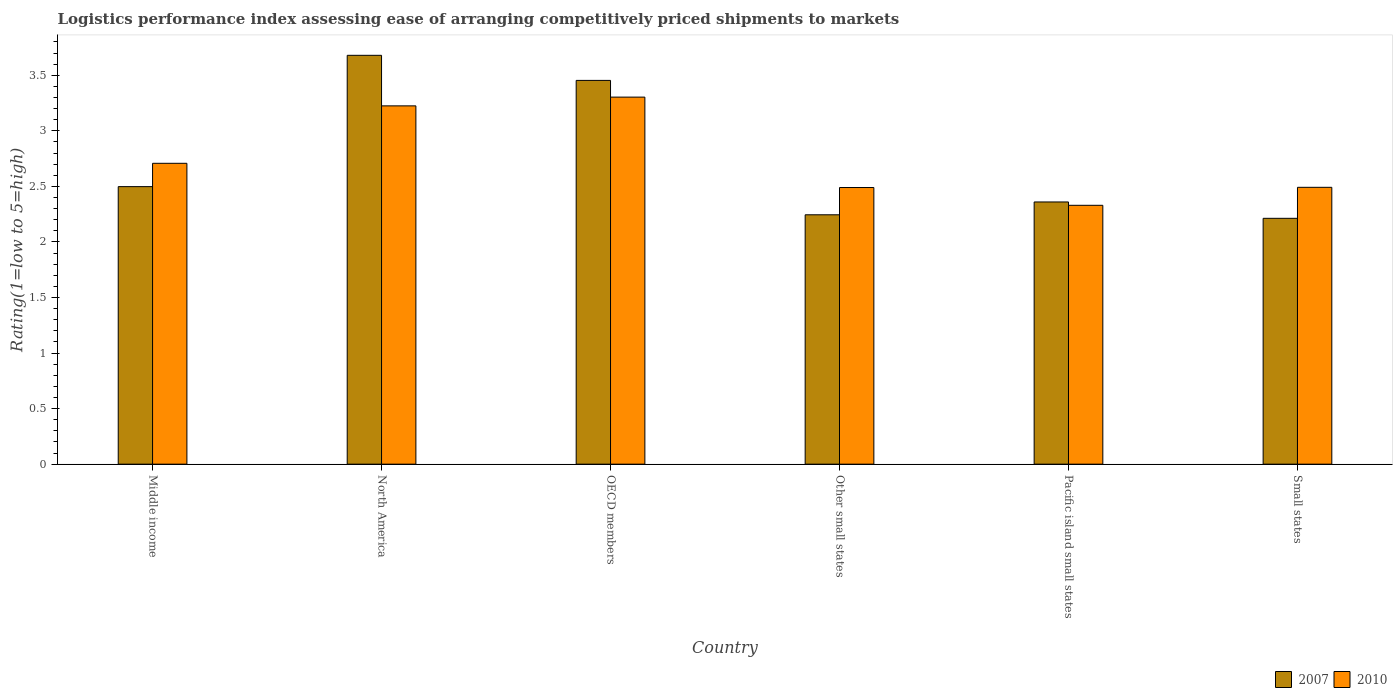How many different coloured bars are there?
Offer a very short reply. 2. How many groups of bars are there?
Give a very brief answer. 6. Are the number of bars on each tick of the X-axis equal?
Keep it short and to the point. Yes. How many bars are there on the 5th tick from the right?
Your answer should be very brief. 2. What is the label of the 5th group of bars from the left?
Your answer should be compact. Pacific island small states. What is the Logistic performance index in 2010 in OECD members?
Keep it short and to the point. 3.3. Across all countries, what is the maximum Logistic performance index in 2007?
Ensure brevity in your answer.  3.68. Across all countries, what is the minimum Logistic performance index in 2007?
Offer a terse response. 2.21. In which country was the Logistic performance index in 2007 maximum?
Your answer should be compact. North America. In which country was the Logistic performance index in 2007 minimum?
Offer a very short reply. Small states. What is the total Logistic performance index in 2010 in the graph?
Make the answer very short. 16.55. What is the difference between the Logistic performance index in 2010 in North America and that in Pacific island small states?
Provide a succinct answer. 0.9. What is the difference between the Logistic performance index in 2010 in Pacific island small states and the Logistic performance index in 2007 in North America?
Your answer should be compact. -1.35. What is the average Logistic performance index in 2007 per country?
Offer a terse response. 2.74. What is the difference between the Logistic performance index of/in 2007 and Logistic performance index of/in 2010 in Small states?
Your response must be concise. -0.28. What is the ratio of the Logistic performance index in 2010 in North America to that in Other small states?
Your answer should be compact. 1.3. Is the difference between the Logistic performance index in 2007 in North America and Small states greater than the difference between the Logistic performance index in 2010 in North America and Small states?
Ensure brevity in your answer.  Yes. What is the difference between the highest and the second highest Logistic performance index in 2010?
Your response must be concise. 0.52. What is the difference between the highest and the lowest Logistic performance index in 2010?
Provide a short and direct response. 0.97. In how many countries, is the Logistic performance index in 2007 greater than the average Logistic performance index in 2007 taken over all countries?
Your answer should be compact. 2. Does the graph contain any zero values?
Make the answer very short. No. Does the graph contain grids?
Your answer should be compact. No. Where does the legend appear in the graph?
Make the answer very short. Bottom right. How many legend labels are there?
Your answer should be compact. 2. How are the legend labels stacked?
Provide a short and direct response. Horizontal. What is the title of the graph?
Give a very brief answer. Logistics performance index assessing ease of arranging competitively priced shipments to markets. What is the label or title of the Y-axis?
Offer a very short reply. Rating(1=low to 5=high). What is the Rating(1=low to 5=high) in 2007 in Middle income?
Offer a terse response. 2.5. What is the Rating(1=low to 5=high) of 2010 in Middle income?
Make the answer very short. 2.71. What is the Rating(1=low to 5=high) of 2007 in North America?
Your answer should be very brief. 3.68. What is the Rating(1=low to 5=high) of 2010 in North America?
Offer a very short reply. 3.23. What is the Rating(1=low to 5=high) of 2007 in OECD members?
Your answer should be compact. 3.45. What is the Rating(1=low to 5=high) of 2010 in OECD members?
Keep it short and to the point. 3.3. What is the Rating(1=low to 5=high) in 2007 in Other small states?
Offer a terse response. 2.24. What is the Rating(1=low to 5=high) of 2010 in Other small states?
Give a very brief answer. 2.49. What is the Rating(1=low to 5=high) in 2007 in Pacific island small states?
Give a very brief answer. 2.36. What is the Rating(1=low to 5=high) of 2010 in Pacific island small states?
Offer a very short reply. 2.33. What is the Rating(1=low to 5=high) of 2007 in Small states?
Your answer should be very brief. 2.21. What is the Rating(1=low to 5=high) of 2010 in Small states?
Provide a short and direct response. 2.49. Across all countries, what is the maximum Rating(1=low to 5=high) of 2007?
Your response must be concise. 3.68. Across all countries, what is the maximum Rating(1=low to 5=high) in 2010?
Give a very brief answer. 3.3. Across all countries, what is the minimum Rating(1=low to 5=high) in 2007?
Your answer should be compact. 2.21. Across all countries, what is the minimum Rating(1=low to 5=high) in 2010?
Provide a short and direct response. 2.33. What is the total Rating(1=low to 5=high) of 2007 in the graph?
Provide a succinct answer. 16.45. What is the total Rating(1=low to 5=high) of 2010 in the graph?
Provide a short and direct response. 16.55. What is the difference between the Rating(1=low to 5=high) in 2007 in Middle income and that in North America?
Make the answer very short. -1.18. What is the difference between the Rating(1=low to 5=high) of 2010 in Middle income and that in North America?
Provide a short and direct response. -0.52. What is the difference between the Rating(1=low to 5=high) in 2007 in Middle income and that in OECD members?
Make the answer very short. -0.96. What is the difference between the Rating(1=low to 5=high) in 2010 in Middle income and that in OECD members?
Keep it short and to the point. -0.6. What is the difference between the Rating(1=low to 5=high) of 2007 in Middle income and that in Other small states?
Make the answer very short. 0.25. What is the difference between the Rating(1=low to 5=high) of 2010 in Middle income and that in Other small states?
Keep it short and to the point. 0.22. What is the difference between the Rating(1=low to 5=high) in 2007 in Middle income and that in Pacific island small states?
Your response must be concise. 0.14. What is the difference between the Rating(1=low to 5=high) in 2010 in Middle income and that in Pacific island small states?
Offer a terse response. 0.38. What is the difference between the Rating(1=low to 5=high) in 2007 in Middle income and that in Small states?
Offer a very short reply. 0.29. What is the difference between the Rating(1=low to 5=high) in 2010 in Middle income and that in Small states?
Provide a succinct answer. 0.22. What is the difference between the Rating(1=low to 5=high) of 2007 in North America and that in OECD members?
Make the answer very short. 0.23. What is the difference between the Rating(1=low to 5=high) in 2010 in North America and that in OECD members?
Your answer should be very brief. -0.08. What is the difference between the Rating(1=low to 5=high) in 2007 in North America and that in Other small states?
Your answer should be compact. 1.44. What is the difference between the Rating(1=low to 5=high) of 2010 in North America and that in Other small states?
Provide a succinct answer. 0.73. What is the difference between the Rating(1=low to 5=high) of 2007 in North America and that in Pacific island small states?
Make the answer very short. 1.32. What is the difference between the Rating(1=low to 5=high) in 2010 in North America and that in Pacific island small states?
Your answer should be very brief. 0.9. What is the difference between the Rating(1=low to 5=high) of 2007 in North America and that in Small states?
Provide a short and direct response. 1.47. What is the difference between the Rating(1=low to 5=high) of 2010 in North America and that in Small states?
Ensure brevity in your answer.  0.73. What is the difference between the Rating(1=low to 5=high) of 2007 in OECD members and that in Other small states?
Provide a short and direct response. 1.21. What is the difference between the Rating(1=low to 5=high) of 2010 in OECD members and that in Other small states?
Provide a short and direct response. 0.81. What is the difference between the Rating(1=low to 5=high) of 2007 in OECD members and that in Pacific island small states?
Provide a succinct answer. 1.09. What is the difference between the Rating(1=low to 5=high) in 2010 in OECD members and that in Pacific island small states?
Keep it short and to the point. 0.97. What is the difference between the Rating(1=low to 5=high) of 2007 in OECD members and that in Small states?
Ensure brevity in your answer.  1.24. What is the difference between the Rating(1=low to 5=high) of 2010 in OECD members and that in Small states?
Make the answer very short. 0.81. What is the difference between the Rating(1=low to 5=high) in 2007 in Other small states and that in Pacific island small states?
Make the answer very short. -0.12. What is the difference between the Rating(1=low to 5=high) of 2010 in Other small states and that in Pacific island small states?
Provide a short and direct response. 0.16. What is the difference between the Rating(1=low to 5=high) of 2007 in Other small states and that in Small states?
Your response must be concise. 0.03. What is the difference between the Rating(1=low to 5=high) of 2010 in Other small states and that in Small states?
Your response must be concise. -0. What is the difference between the Rating(1=low to 5=high) of 2007 in Pacific island small states and that in Small states?
Your response must be concise. 0.15. What is the difference between the Rating(1=low to 5=high) in 2010 in Pacific island small states and that in Small states?
Your answer should be very brief. -0.16. What is the difference between the Rating(1=low to 5=high) in 2007 in Middle income and the Rating(1=low to 5=high) in 2010 in North America?
Your response must be concise. -0.73. What is the difference between the Rating(1=low to 5=high) of 2007 in Middle income and the Rating(1=low to 5=high) of 2010 in OECD members?
Offer a terse response. -0.81. What is the difference between the Rating(1=low to 5=high) of 2007 in Middle income and the Rating(1=low to 5=high) of 2010 in Other small states?
Give a very brief answer. 0.01. What is the difference between the Rating(1=low to 5=high) in 2007 in Middle income and the Rating(1=low to 5=high) in 2010 in Pacific island small states?
Your answer should be compact. 0.17. What is the difference between the Rating(1=low to 5=high) in 2007 in Middle income and the Rating(1=low to 5=high) in 2010 in Small states?
Provide a succinct answer. 0.01. What is the difference between the Rating(1=low to 5=high) of 2007 in North America and the Rating(1=low to 5=high) of 2010 in OECD members?
Offer a very short reply. 0.38. What is the difference between the Rating(1=low to 5=high) of 2007 in North America and the Rating(1=low to 5=high) of 2010 in Other small states?
Ensure brevity in your answer.  1.19. What is the difference between the Rating(1=low to 5=high) of 2007 in North America and the Rating(1=low to 5=high) of 2010 in Pacific island small states?
Give a very brief answer. 1.35. What is the difference between the Rating(1=low to 5=high) in 2007 in North America and the Rating(1=low to 5=high) in 2010 in Small states?
Keep it short and to the point. 1.19. What is the difference between the Rating(1=low to 5=high) in 2007 in OECD members and the Rating(1=low to 5=high) in 2010 in Other small states?
Make the answer very short. 0.96. What is the difference between the Rating(1=low to 5=high) in 2007 in OECD members and the Rating(1=low to 5=high) in 2010 in Pacific island small states?
Make the answer very short. 1.12. What is the difference between the Rating(1=low to 5=high) of 2007 in OECD members and the Rating(1=low to 5=high) of 2010 in Small states?
Your answer should be compact. 0.96. What is the difference between the Rating(1=low to 5=high) in 2007 in Other small states and the Rating(1=low to 5=high) in 2010 in Pacific island small states?
Provide a succinct answer. -0.09. What is the difference between the Rating(1=low to 5=high) in 2007 in Other small states and the Rating(1=low to 5=high) in 2010 in Small states?
Your answer should be compact. -0.25. What is the difference between the Rating(1=low to 5=high) of 2007 in Pacific island small states and the Rating(1=low to 5=high) of 2010 in Small states?
Your response must be concise. -0.13. What is the average Rating(1=low to 5=high) in 2007 per country?
Provide a succinct answer. 2.74. What is the average Rating(1=low to 5=high) in 2010 per country?
Ensure brevity in your answer.  2.76. What is the difference between the Rating(1=low to 5=high) in 2007 and Rating(1=low to 5=high) in 2010 in Middle income?
Offer a very short reply. -0.21. What is the difference between the Rating(1=low to 5=high) in 2007 and Rating(1=low to 5=high) in 2010 in North America?
Provide a short and direct response. 0.46. What is the difference between the Rating(1=low to 5=high) of 2007 and Rating(1=low to 5=high) of 2010 in OECD members?
Provide a succinct answer. 0.15. What is the difference between the Rating(1=low to 5=high) of 2007 and Rating(1=low to 5=high) of 2010 in Other small states?
Provide a succinct answer. -0.25. What is the difference between the Rating(1=low to 5=high) in 2007 and Rating(1=low to 5=high) in 2010 in Pacific island small states?
Provide a succinct answer. 0.03. What is the difference between the Rating(1=low to 5=high) in 2007 and Rating(1=low to 5=high) in 2010 in Small states?
Keep it short and to the point. -0.28. What is the ratio of the Rating(1=low to 5=high) of 2007 in Middle income to that in North America?
Provide a short and direct response. 0.68. What is the ratio of the Rating(1=low to 5=high) of 2010 in Middle income to that in North America?
Keep it short and to the point. 0.84. What is the ratio of the Rating(1=low to 5=high) in 2007 in Middle income to that in OECD members?
Give a very brief answer. 0.72. What is the ratio of the Rating(1=low to 5=high) of 2010 in Middle income to that in OECD members?
Ensure brevity in your answer.  0.82. What is the ratio of the Rating(1=low to 5=high) in 2007 in Middle income to that in Other small states?
Your response must be concise. 1.11. What is the ratio of the Rating(1=low to 5=high) in 2010 in Middle income to that in Other small states?
Make the answer very short. 1.09. What is the ratio of the Rating(1=low to 5=high) of 2007 in Middle income to that in Pacific island small states?
Give a very brief answer. 1.06. What is the ratio of the Rating(1=low to 5=high) in 2010 in Middle income to that in Pacific island small states?
Your response must be concise. 1.16. What is the ratio of the Rating(1=low to 5=high) of 2007 in Middle income to that in Small states?
Give a very brief answer. 1.13. What is the ratio of the Rating(1=low to 5=high) in 2010 in Middle income to that in Small states?
Give a very brief answer. 1.09. What is the ratio of the Rating(1=low to 5=high) of 2007 in North America to that in OECD members?
Provide a succinct answer. 1.07. What is the ratio of the Rating(1=low to 5=high) of 2010 in North America to that in OECD members?
Ensure brevity in your answer.  0.98. What is the ratio of the Rating(1=low to 5=high) in 2007 in North America to that in Other small states?
Your response must be concise. 1.64. What is the ratio of the Rating(1=low to 5=high) of 2010 in North America to that in Other small states?
Offer a terse response. 1.3. What is the ratio of the Rating(1=low to 5=high) of 2007 in North America to that in Pacific island small states?
Your answer should be compact. 1.56. What is the ratio of the Rating(1=low to 5=high) of 2010 in North America to that in Pacific island small states?
Offer a very short reply. 1.38. What is the ratio of the Rating(1=low to 5=high) in 2007 in North America to that in Small states?
Provide a succinct answer. 1.66. What is the ratio of the Rating(1=low to 5=high) in 2010 in North America to that in Small states?
Your response must be concise. 1.29. What is the ratio of the Rating(1=low to 5=high) in 2007 in OECD members to that in Other small states?
Your answer should be compact. 1.54. What is the ratio of the Rating(1=low to 5=high) of 2010 in OECD members to that in Other small states?
Give a very brief answer. 1.33. What is the ratio of the Rating(1=low to 5=high) of 2007 in OECD members to that in Pacific island small states?
Provide a short and direct response. 1.46. What is the ratio of the Rating(1=low to 5=high) of 2010 in OECD members to that in Pacific island small states?
Make the answer very short. 1.42. What is the ratio of the Rating(1=low to 5=high) of 2007 in OECD members to that in Small states?
Provide a succinct answer. 1.56. What is the ratio of the Rating(1=low to 5=high) of 2010 in OECD members to that in Small states?
Ensure brevity in your answer.  1.33. What is the ratio of the Rating(1=low to 5=high) in 2007 in Other small states to that in Pacific island small states?
Offer a terse response. 0.95. What is the ratio of the Rating(1=low to 5=high) of 2010 in Other small states to that in Pacific island small states?
Ensure brevity in your answer.  1.07. What is the ratio of the Rating(1=low to 5=high) of 2007 in Other small states to that in Small states?
Your answer should be compact. 1.01. What is the ratio of the Rating(1=low to 5=high) in 2010 in Other small states to that in Small states?
Offer a terse response. 1. What is the ratio of the Rating(1=low to 5=high) in 2007 in Pacific island small states to that in Small states?
Make the answer very short. 1.07. What is the ratio of the Rating(1=low to 5=high) in 2010 in Pacific island small states to that in Small states?
Your response must be concise. 0.94. What is the difference between the highest and the second highest Rating(1=low to 5=high) of 2007?
Provide a short and direct response. 0.23. What is the difference between the highest and the second highest Rating(1=low to 5=high) of 2010?
Keep it short and to the point. 0.08. What is the difference between the highest and the lowest Rating(1=low to 5=high) of 2007?
Make the answer very short. 1.47. What is the difference between the highest and the lowest Rating(1=low to 5=high) of 2010?
Your response must be concise. 0.97. 